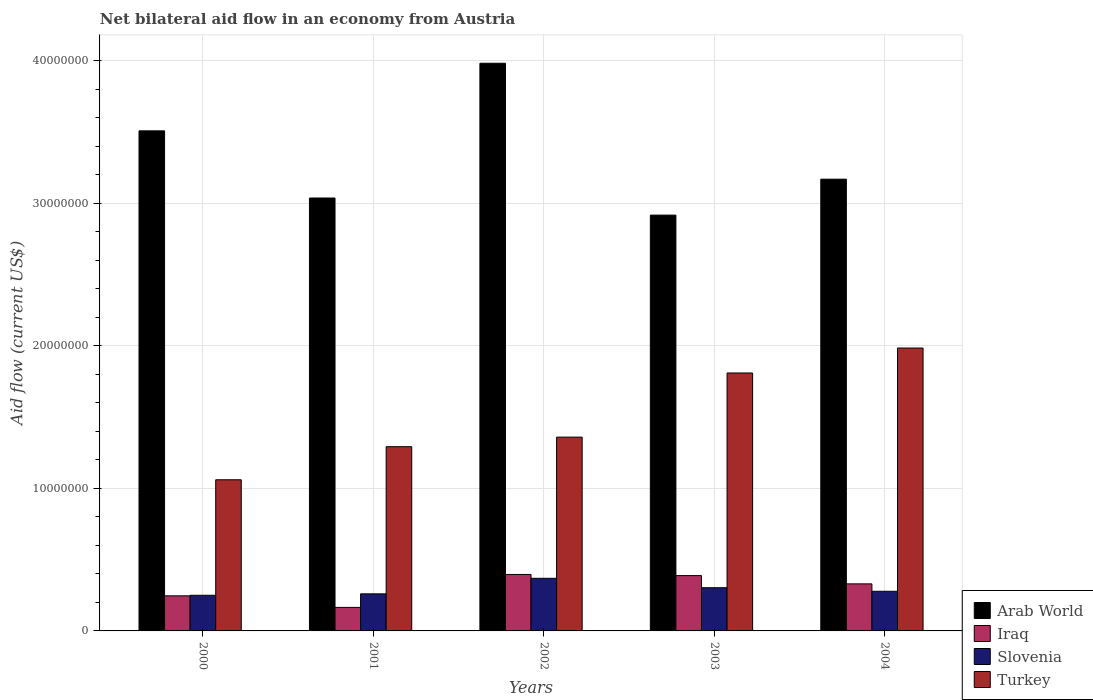Are the number of bars on each tick of the X-axis equal?
Provide a succinct answer. Yes. How many bars are there on the 4th tick from the left?
Offer a terse response. 4. What is the net bilateral aid flow in Iraq in 2002?
Ensure brevity in your answer.  3.96e+06. Across all years, what is the maximum net bilateral aid flow in Arab World?
Give a very brief answer. 3.98e+07. Across all years, what is the minimum net bilateral aid flow in Iraq?
Keep it short and to the point. 1.65e+06. In which year was the net bilateral aid flow in Iraq maximum?
Offer a terse response. 2002. What is the total net bilateral aid flow in Slovenia in the graph?
Offer a terse response. 1.46e+07. What is the difference between the net bilateral aid flow in Slovenia in 2001 and the net bilateral aid flow in Iraq in 2002?
Provide a succinct answer. -1.36e+06. What is the average net bilateral aid flow in Turkey per year?
Provide a short and direct response. 1.50e+07. In the year 2004, what is the difference between the net bilateral aid flow in Iraq and net bilateral aid flow in Turkey?
Ensure brevity in your answer.  -1.65e+07. What is the ratio of the net bilateral aid flow in Arab World in 2000 to that in 2003?
Provide a succinct answer. 1.2. What is the difference between the highest and the lowest net bilateral aid flow in Arab World?
Offer a very short reply. 1.06e+07. Is the sum of the net bilateral aid flow in Iraq in 2001 and 2004 greater than the maximum net bilateral aid flow in Slovenia across all years?
Provide a short and direct response. Yes. Is it the case that in every year, the sum of the net bilateral aid flow in Slovenia and net bilateral aid flow in Turkey is greater than the sum of net bilateral aid flow in Iraq and net bilateral aid flow in Arab World?
Provide a short and direct response. No. What does the 2nd bar from the left in 2003 represents?
Offer a very short reply. Iraq. How many years are there in the graph?
Make the answer very short. 5. What is the difference between two consecutive major ticks on the Y-axis?
Make the answer very short. 1.00e+07. Does the graph contain any zero values?
Offer a terse response. No. Where does the legend appear in the graph?
Provide a succinct answer. Bottom right. What is the title of the graph?
Your response must be concise. Net bilateral aid flow in an economy from Austria. What is the label or title of the X-axis?
Offer a very short reply. Years. What is the label or title of the Y-axis?
Provide a short and direct response. Aid flow (current US$). What is the Aid flow (current US$) in Arab World in 2000?
Your answer should be compact. 3.51e+07. What is the Aid flow (current US$) in Iraq in 2000?
Make the answer very short. 2.46e+06. What is the Aid flow (current US$) of Slovenia in 2000?
Give a very brief answer. 2.50e+06. What is the Aid flow (current US$) in Turkey in 2000?
Offer a terse response. 1.06e+07. What is the Aid flow (current US$) in Arab World in 2001?
Provide a succinct answer. 3.04e+07. What is the Aid flow (current US$) in Iraq in 2001?
Offer a terse response. 1.65e+06. What is the Aid flow (current US$) of Slovenia in 2001?
Your answer should be compact. 2.60e+06. What is the Aid flow (current US$) of Turkey in 2001?
Provide a succinct answer. 1.29e+07. What is the Aid flow (current US$) of Arab World in 2002?
Give a very brief answer. 3.98e+07. What is the Aid flow (current US$) in Iraq in 2002?
Give a very brief answer. 3.96e+06. What is the Aid flow (current US$) in Slovenia in 2002?
Your answer should be compact. 3.69e+06. What is the Aid flow (current US$) in Turkey in 2002?
Provide a succinct answer. 1.36e+07. What is the Aid flow (current US$) of Arab World in 2003?
Your answer should be very brief. 2.92e+07. What is the Aid flow (current US$) in Iraq in 2003?
Your response must be concise. 3.88e+06. What is the Aid flow (current US$) in Slovenia in 2003?
Give a very brief answer. 3.03e+06. What is the Aid flow (current US$) in Turkey in 2003?
Offer a terse response. 1.81e+07. What is the Aid flow (current US$) of Arab World in 2004?
Your response must be concise. 3.17e+07. What is the Aid flow (current US$) of Iraq in 2004?
Make the answer very short. 3.30e+06. What is the Aid flow (current US$) in Slovenia in 2004?
Your answer should be very brief. 2.78e+06. What is the Aid flow (current US$) in Turkey in 2004?
Give a very brief answer. 1.98e+07. Across all years, what is the maximum Aid flow (current US$) in Arab World?
Provide a succinct answer. 3.98e+07. Across all years, what is the maximum Aid flow (current US$) in Iraq?
Make the answer very short. 3.96e+06. Across all years, what is the maximum Aid flow (current US$) of Slovenia?
Your answer should be very brief. 3.69e+06. Across all years, what is the maximum Aid flow (current US$) of Turkey?
Keep it short and to the point. 1.98e+07. Across all years, what is the minimum Aid flow (current US$) in Arab World?
Your answer should be very brief. 2.92e+07. Across all years, what is the minimum Aid flow (current US$) in Iraq?
Keep it short and to the point. 1.65e+06. Across all years, what is the minimum Aid flow (current US$) of Slovenia?
Give a very brief answer. 2.50e+06. Across all years, what is the minimum Aid flow (current US$) of Turkey?
Make the answer very short. 1.06e+07. What is the total Aid flow (current US$) of Arab World in the graph?
Your response must be concise. 1.66e+08. What is the total Aid flow (current US$) in Iraq in the graph?
Ensure brevity in your answer.  1.52e+07. What is the total Aid flow (current US$) in Slovenia in the graph?
Provide a short and direct response. 1.46e+07. What is the total Aid flow (current US$) of Turkey in the graph?
Make the answer very short. 7.50e+07. What is the difference between the Aid flow (current US$) of Arab World in 2000 and that in 2001?
Ensure brevity in your answer.  4.71e+06. What is the difference between the Aid flow (current US$) in Iraq in 2000 and that in 2001?
Your response must be concise. 8.10e+05. What is the difference between the Aid flow (current US$) in Turkey in 2000 and that in 2001?
Make the answer very short. -2.32e+06. What is the difference between the Aid flow (current US$) of Arab World in 2000 and that in 2002?
Give a very brief answer. -4.74e+06. What is the difference between the Aid flow (current US$) in Iraq in 2000 and that in 2002?
Offer a terse response. -1.50e+06. What is the difference between the Aid flow (current US$) in Slovenia in 2000 and that in 2002?
Provide a succinct answer. -1.19e+06. What is the difference between the Aid flow (current US$) of Turkey in 2000 and that in 2002?
Ensure brevity in your answer.  -2.99e+06. What is the difference between the Aid flow (current US$) of Arab World in 2000 and that in 2003?
Keep it short and to the point. 5.91e+06. What is the difference between the Aid flow (current US$) of Iraq in 2000 and that in 2003?
Offer a terse response. -1.42e+06. What is the difference between the Aid flow (current US$) in Slovenia in 2000 and that in 2003?
Your answer should be very brief. -5.30e+05. What is the difference between the Aid flow (current US$) in Turkey in 2000 and that in 2003?
Give a very brief answer. -7.49e+06. What is the difference between the Aid flow (current US$) of Arab World in 2000 and that in 2004?
Make the answer very short. 3.39e+06. What is the difference between the Aid flow (current US$) of Iraq in 2000 and that in 2004?
Offer a very short reply. -8.40e+05. What is the difference between the Aid flow (current US$) in Slovenia in 2000 and that in 2004?
Offer a terse response. -2.80e+05. What is the difference between the Aid flow (current US$) of Turkey in 2000 and that in 2004?
Offer a very short reply. -9.24e+06. What is the difference between the Aid flow (current US$) of Arab World in 2001 and that in 2002?
Your answer should be very brief. -9.45e+06. What is the difference between the Aid flow (current US$) of Iraq in 2001 and that in 2002?
Your answer should be compact. -2.31e+06. What is the difference between the Aid flow (current US$) of Slovenia in 2001 and that in 2002?
Give a very brief answer. -1.09e+06. What is the difference between the Aid flow (current US$) in Turkey in 2001 and that in 2002?
Your answer should be compact. -6.70e+05. What is the difference between the Aid flow (current US$) in Arab World in 2001 and that in 2003?
Your answer should be compact. 1.20e+06. What is the difference between the Aid flow (current US$) of Iraq in 2001 and that in 2003?
Ensure brevity in your answer.  -2.23e+06. What is the difference between the Aid flow (current US$) in Slovenia in 2001 and that in 2003?
Keep it short and to the point. -4.30e+05. What is the difference between the Aid flow (current US$) of Turkey in 2001 and that in 2003?
Your answer should be compact. -5.17e+06. What is the difference between the Aid flow (current US$) in Arab World in 2001 and that in 2004?
Your answer should be very brief. -1.32e+06. What is the difference between the Aid flow (current US$) of Iraq in 2001 and that in 2004?
Your response must be concise. -1.65e+06. What is the difference between the Aid flow (current US$) in Turkey in 2001 and that in 2004?
Provide a short and direct response. -6.92e+06. What is the difference between the Aid flow (current US$) in Arab World in 2002 and that in 2003?
Make the answer very short. 1.06e+07. What is the difference between the Aid flow (current US$) of Turkey in 2002 and that in 2003?
Provide a succinct answer. -4.50e+06. What is the difference between the Aid flow (current US$) of Arab World in 2002 and that in 2004?
Ensure brevity in your answer.  8.13e+06. What is the difference between the Aid flow (current US$) of Iraq in 2002 and that in 2004?
Provide a succinct answer. 6.60e+05. What is the difference between the Aid flow (current US$) in Slovenia in 2002 and that in 2004?
Keep it short and to the point. 9.10e+05. What is the difference between the Aid flow (current US$) of Turkey in 2002 and that in 2004?
Your answer should be compact. -6.25e+06. What is the difference between the Aid flow (current US$) of Arab World in 2003 and that in 2004?
Offer a terse response. -2.52e+06. What is the difference between the Aid flow (current US$) of Iraq in 2003 and that in 2004?
Your answer should be compact. 5.80e+05. What is the difference between the Aid flow (current US$) in Turkey in 2003 and that in 2004?
Provide a succinct answer. -1.75e+06. What is the difference between the Aid flow (current US$) of Arab World in 2000 and the Aid flow (current US$) of Iraq in 2001?
Provide a short and direct response. 3.34e+07. What is the difference between the Aid flow (current US$) in Arab World in 2000 and the Aid flow (current US$) in Slovenia in 2001?
Make the answer very short. 3.25e+07. What is the difference between the Aid flow (current US$) in Arab World in 2000 and the Aid flow (current US$) in Turkey in 2001?
Give a very brief answer. 2.22e+07. What is the difference between the Aid flow (current US$) of Iraq in 2000 and the Aid flow (current US$) of Turkey in 2001?
Your answer should be very brief. -1.05e+07. What is the difference between the Aid flow (current US$) in Slovenia in 2000 and the Aid flow (current US$) in Turkey in 2001?
Keep it short and to the point. -1.04e+07. What is the difference between the Aid flow (current US$) of Arab World in 2000 and the Aid flow (current US$) of Iraq in 2002?
Keep it short and to the point. 3.11e+07. What is the difference between the Aid flow (current US$) of Arab World in 2000 and the Aid flow (current US$) of Slovenia in 2002?
Give a very brief answer. 3.14e+07. What is the difference between the Aid flow (current US$) in Arab World in 2000 and the Aid flow (current US$) in Turkey in 2002?
Your response must be concise. 2.15e+07. What is the difference between the Aid flow (current US$) in Iraq in 2000 and the Aid flow (current US$) in Slovenia in 2002?
Your answer should be very brief. -1.23e+06. What is the difference between the Aid flow (current US$) of Iraq in 2000 and the Aid flow (current US$) of Turkey in 2002?
Provide a short and direct response. -1.11e+07. What is the difference between the Aid flow (current US$) of Slovenia in 2000 and the Aid flow (current US$) of Turkey in 2002?
Offer a terse response. -1.11e+07. What is the difference between the Aid flow (current US$) of Arab World in 2000 and the Aid flow (current US$) of Iraq in 2003?
Your answer should be compact. 3.12e+07. What is the difference between the Aid flow (current US$) of Arab World in 2000 and the Aid flow (current US$) of Slovenia in 2003?
Offer a terse response. 3.20e+07. What is the difference between the Aid flow (current US$) of Arab World in 2000 and the Aid flow (current US$) of Turkey in 2003?
Give a very brief answer. 1.70e+07. What is the difference between the Aid flow (current US$) of Iraq in 2000 and the Aid flow (current US$) of Slovenia in 2003?
Give a very brief answer. -5.70e+05. What is the difference between the Aid flow (current US$) of Iraq in 2000 and the Aid flow (current US$) of Turkey in 2003?
Your answer should be compact. -1.56e+07. What is the difference between the Aid flow (current US$) in Slovenia in 2000 and the Aid flow (current US$) in Turkey in 2003?
Your answer should be compact. -1.56e+07. What is the difference between the Aid flow (current US$) in Arab World in 2000 and the Aid flow (current US$) in Iraq in 2004?
Ensure brevity in your answer.  3.18e+07. What is the difference between the Aid flow (current US$) in Arab World in 2000 and the Aid flow (current US$) in Slovenia in 2004?
Your answer should be very brief. 3.23e+07. What is the difference between the Aid flow (current US$) in Arab World in 2000 and the Aid flow (current US$) in Turkey in 2004?
Give a very brief answer. 1.52e+07. What is the difference between the Aid flow (current US$) in Iraq in 2000 and the Aid flow (current US$) in Slovenia in 2004?
Offer a terse response. -3.20e+05. What is the difference between the Aid flow (current US$) in Iraq in 2000 and the Aid flow (current US$) in Turkey in 2004?
Ensure brevity in your answer.  -1.74e+07. What is the difference between the Aid flow (current US$) in Slovenia in 2000 and the Aid flow (current US$) in Turkey in 2004?
Provide a short and direct response. -1.73e+07. What is the difference between the Aid flow (current US$) in Arab World in 2001 and the Aid flow (current US$) in Iraq in 2002?
Your response must be concise. 2.64e+07. What is the difference between the Aid flow (current US$) of Arab World in 2001 and the Aid flow (current US$) of Slovenia in 2002?
Give a very brief answer. 2.67e+07. What is the difference between the Aid flow (current US$) in Arab World in 2001 and the Aid flow (current US$) in Turkey in 2002?
Offer a very short reply. 1.68e+07. What is the difference between the Aid flow (current US$) in Iraq in 2001 and the Aid flow (current US$) in Slovenia in 2002?
Keep it short and to the point. -2.04e+06. What is the difference between the Aid flow (current US$) of Iraq in 2001 and the Aid flow (current US$) of Turkey in 2002?
Provide a succinct answer. -1.19e+07. What is the difference between the Aid flow (current US$) in Slovenia in 2001 and the Aid flow (current US$) in Turkey in 2002?
Your response must be concise. -1.10e+07. What is the difference between the Aid flow (current US$) in Arab World in 2001 and the Aid flow (current US$) in Iraq in 2003?
Ensure brevity in your answer.  2.65e+07. What is the difference between the Aid flow (current US$) in Arab World in 2001 and the Aid flow (current US$) in Slovenia in 2003?
Offer a very short reply. 2.73e+07. What is the difference between the Aid flow (current US$) in Arab World in 2001 and the Aid flow (current US$) in Turkey in 2003?
Your response must be concise. 1.23e+07. What is the difference between the Aid flow (current US$) of Iraq in 2001 and the Aid flow (current US$) of Slovenia in 2003?
Make the answer very short. -1.38e+06. What is the difference between the Aid flow (current US$) in Iraq in 2001 and the Aid flow (current US$) in Turkey in 2003?
Provide a succinct answer. -1.64e+07. What is the difference between the Aid flow (current US$) of Slovenia in 2001 and the Aid flow (current US$) of Turkey in 2003?
Offer a terse response. -1.55e+07. What is the difference between the Aid flow (current US$) of Arab World in 2001 and the Aid flow (current US$) of Iraq in 2004?
Provide a succinct answer. 2.71e+07. What is the difference between the Aid flow (current US$) of Arab World in 2001 and the Aid flow (current US$) of Slovenia in 2004?
Provide a succinct answer. 2.76e+07. What is the difference between the Aid flow (current US$) of Arab World in 2001 and the Aid flow (current US$) of Turkey in 2004?
Give a very brief answer. 1.05e+07. What is the difference between the Aid flow (current US$) of Iraq in 2001 and the Aid flow (current US$) of Slovenia in 2004?
Make the answer very short. -1.13e+06. What is the difference between the Aid flow (current US$) in Iraq in 2001 and the Aid flow (current US$) in Turkey in 2004?
Ensure brevity in your answer.  -1.82e+07. What is the difference between the Aid flow (current US$) in Slovenia in 2001 and the Aid flow (current US$) in Turkey in 2004?
Your answer should be compact. -1.72e+07. What is the difference between the Aid flow (current US$) of Arab World in 2002 and the Aid flow (current US$) of Iraq in 2003?
Your response must be concise. 3.59e+07. What is the difference between the Aid flow (current US$) of Arab World in 2002 and the Aid flow (current US$) of Slovenia in 2003?
Your answer should be compact. 3.68e+07. What is the difference between the Aid flow (current US$) of Arab World in 2002 and the Aid flow (current US$) of Turkey in 2003?
Your answer should be compact. 2.17e+07. What is the difference between the Aid flow (current US$) in Iraq in 2002 and the Aid flow (current US$) in Slovenia in 2003?
Your response must be concise. 9.30e+05. What is the difference between the Aid flow (current US$) in Iraq in 2002 and the Aid flow (current US$) in Turkey in 2003?
Your response must be concise. -1.41e+07. What is the difference between the Aid flow (current US$) of Slovenia in 2002 and the Aid flow (current US$) of Turkey in 2003?
Provide a short and direct response. -1.44e+07. What is the difference between the Aid flow (current US$) of Arab World in 2002 and the Aid flow (current US$) of Iraq in 2004?
Your answer should be compact. 3.65e+07. What is the difference between the Aid flow (current US$) in Arab World in 2002 and the Aid flow (current US$) in Slovenia in 2004?
Ensure brevity in your answer.  3.70e+07. What is the difference between the Aid flow (current US$) in Arab World in 2002 and the Aid flow (current US$) in Turkey in 2004?
Provide a short and direct response. 2.00e+07. What is the difference between the Aid flow (current US$) in Iraq in 2002 and the Aid flow (current US$) in Slovenia in 2004?
Your answer should be very brief. 1.18e+06. What is the difference between the Aid flow (current US$) in Iraq in 2002 and the Aid flow (current US$) in Turkey in 2004?
Keep it short and to the point. -1.59e+07. What is the difference between the Aid flow (current US$) of Slovenia in 2002 and the Aid flow (current US$) of Turkey in 2004?
Give a very brief answer. -1.62e+07. What is the difference between the Aid flow (current US$) in Arab World in 2003 and the Aid flow (current US$) in Iraq in 2004?
Your answer should be compact. 2.59e+07. What is the difference between the Aid flow (current US$) in Arab World in 2003 and the Aid flow (current US$) in Slovenia in 2004?
Provide a short and direct response. 2.64e+07. What is the difference between the Aid flow (current US$) in Arab World in 2003 and the Aid flow (current US$) in Turkey in 2004?
Provide a succinct answer. 9.32e+06. What is the difference between the Aid flow (current US$) of Iraq in 2003 and the Aid flow (current US$) of Slovenia in 2004?
Ensure brevity in your answer.  1.10e+06. What is the difference between the Aid flow (current US$) in Iraq in 2003 and the Aid flow (current US$) in Turkey in 2004?
Provide a succinct answer. -1.60e+07. What is the difference between the Aid flow (current US$) in Slovenia in 2003 and the Aid flow (current US$) in Turkey in 2004?
Provide a short and direct response. -1.68e+07. What is the average Aid flow (current US$) of Arab World per year?
Offer a terse response. 3.32e+07. What is the average Aid flow (current US$) of Iraq per year?
Your answer should be very brief. 3.05e+06. What is the average Aid flow (current US$) in Slovenia per year?
Provide a short and direct response. 2.92e+06. What is the average Aid flow (current US$) in Turkey per year?
Give a very brief answer. 1.50e+07. In the year 2000, what is the difference between the Aid flow (current US$) in Arab World and Aid flow (current US$) in Iraq?
Give a very brief answer. 3.26e+07. In the year 2000, what is the difference between the Aid flow (current US$) in Arab World and Aid flow (current US$) in Slovenia?
Make the answer very short. 3.26e+07. In the year 2000, what is the difference between the Aid flow (current US$) in Arab World and Aid flow (current US$) in Turkey?
Provide a short and direct response. 2.45e+07. In the year 2000, what is the difference between the Aid flow (current US$) in Iraq and Aid flow (current US$) in Turkey?
Offer a terse response. -8.14e+06. In the year 2000, what is the difference between the Aid flow (current US$) in Slovenia and Aid flow (current US$) in Turkey?
Your answer should be very brief. -8.10e+06. In the year 2001, what is the difference between the Aid flow (current US$) of Arab World and Aid flow (current US$) of Iraq?
Ensure brevity in your answer.  2.87e+07. In the year 2001, what is the difference between the Aid flow (current US$) of Arab World and Aid flow (current US$) of Slovenia?
Provide a succinct answer. 2.78e+07. In the year 2001, what is the difference between the Aid flow (current US$) in Arab World and Aid flow (current US$) in Turkey?
Keep it short and to the point. 1.74e+07. In the year 2001, what is the difference between the Aid flow (current US$) in Iraq and Aid flow (current US$) in Slovenia?
Your answer should be compact. -9.50e+05. In the year 2001, what is the difference between the Aid flow (current US$) in Iraq and Aid flow (current US$) in Turkey?
Provide a succinct answer. -1.13e+07. In the year 2001, what is the difference between the Aid flow (current US$) in Slovenia and Aid flow (current US$) in Turkey?
Your response must be concise. -1.03e+07. In the year 2002, what is the difference between the Aid flow (current US$) in Arab World and Aid flow (current US$) in Iraq?
Your answer should be compact. 3.58e+07. In the year 2002, what is the difference between the Aid flow (current US$) of Arab World and Aid flow (current US$) of Slovenia?
Give a very brief answer. 3.61e+07. In the year 2002, what is the difference between the Aid flow (current US$) in Arab World and Aid flow (current US$) in Turkey?
Keep it short and to the point. 2.62e+07. In the year 2002, what is the difference between the Aid flow (current US$) in Iraq and Aid flow (current US$) in Turkey?
Provide a short and direct response. -9.63e+06. In the year 2002, what is the difference between the Aid flow (current US$) of Slovenia and Aid flow (current US$) of Turkey?
Keep it short and to the point. -9.90e+06. In the year 2003, what is the difference between the Aid flow (current US$) in Arab World and Aid flow (current US$) in Iraq?
Offer a terse response. 2.53e+07. In the year 2003, what is the difference between the Aid flow (current US$) in Arab World and Aid flow (current US$) in Slovenia?
Offer a very short reply. 2.61e+07. In the year 2003, what is the difference between the Aid flow (current US$) in Arab World and Aid flow (current US$) in Turkey?
Keep it short and to the point. 1.11e+07. In the year 2003, what is the difference between the Aid flow (current US$) of Iraq and Aid flow (current US$) of Slovenia?
Ensure brevity in your answer.  8.50e+05. In the year 2003, what is the difference between the Aid flow (current US$) of Iraq and Aid flow (current US$) of Turkey?
Your answer should be very brief. -1.42e+07. In the year 2003, what is the difference between the Aid flow (current US$) in Slovenia and Aid flow (current US$) in Turkey?
Give a very brief answer. -1.51e+07. In the year 2004, what is the difference between the Aid flow (current US$) of Arab World and Aid flow (current US$) of Iraq?
Give a very brief answer. 2.84e+07. In the year 2004, what is the difference between the Aid flow (current US$) in Arab World and Aid flow (current US$) in Slovenia?
Provide a succinct answer. 2.89e+07. In the year 2004, what is the difference between the Aid flow (current US$) of Arab World and Aid flow (current US$) of Turkey?
Ensure brevity in your answer.  1.18e+07. In the year 2004, what is the difference between the Aid flow (current US$) in Iraq and Aid flow (current US$) in Slovenia?
Provide a short and direct response. 5.20e+05. In the year 2004, what is the difference between the Aid flow (current US$) of Iraq and Aid flow (current US$) of Turkey?
Give a very brief answer. -1.65e+07. In the year 2004, what is the difference between the Aid flow (current US$) of Slovenia and Aid flow (current US$) of Turkey?
Keep it short and to the point. -1.71e+07. What is the ratio of the Aid flow (current US$) in Arab World in 2000 to that in 2001?
Your answer should be very brief. 1.16. What is the ratio of the Aid flow (current US$) in Iraq in 2000 to that in 2001?
Offer a very short reply. 1.49. What is the ratio of the Aid flow (current US$) in Slovenia in 2000 to that in 2001?
Your answer should be very brief. 0.96. What is the ratio of the Aid flow (current US$) of Turkey in 2000 to that in 2001?
Keep it short and to the point. 0.82. What is the ratio of the Aid flow (current US$) of Arab World in 2000 to that in 2002?
Offer a terse response. 0.88. What is the ratio of the Aid flow (current US$) in Iraq in 2000 to that in 2002?
Offer a very short reply. 0.62. What is the ratio of the Aid flow (current US$) in Slovenia in 2000 to that in 2002?
Your answer should be very brief. 0.68. What is the ratio of the Aid flow (current US$) in Turkey in 2000 to that in 2002?
Provide a short and direct response. 0.78. What is the ratio of the Aid flow (current US$) of Arab World in 2000 to that in 2003?
Make the answer very short. 1.2. What is the ratio of the Aid flow (current US$) of Iraq in 2000 to that in 2003?
Your answer should be very brief. 0.63. What is the ratio of the Aid flow (current US$) of Slovenia in 2000 to that in 2003?
Make the answer very short. 0.83. What is the ratio of the Aid flow (current US$) of Turkey in 2000 to that in 2003?
Your response must be concise. 0.59. What is the ratio of the Aid flow (current US$) of Arab World in 2000 to that in 2004?
Provide a short and direct response. 1.11. What is the ratio of the Aid flow (current US$) in Iraq in 2000 to that in 2004?
Give a very brief answer. 0.75. What is the ratio of the Aid flow (current US$) in Slovenia in 2000 to that in 2004?
Provide a succinct answer. 0.9. What is the ratio of the Aid flow (current US$) of Turkey in 2000 to that in 2004?
Ensure brevity in your answer.  0.53. What is the ratio of the Aid flow (current US$) of Arab World in 2001 to that in 2002?
Offer a terse response. 0.76. What is the ratio of the Aid flow (current US$) in Iraq in 2001 to that in 2002?
Your answer should be compact. 0.42. What is the ratio of the Aid flow (current US$) in Slovenia in 2001 to that in 2002?
Make the answer very short. 0.7. What is the ratio of the Aid flow (current US$) of Turkey in 2001 to that in 2002?
Your answer should be compact. 0.95. What is the ratio of the Aid flow (current US$) of Arab World in 2001 to that in 2003?
Offer a very short reply. 1.04. What is the ratio of the Aid flow (current US$) of Iraq in 2001 to that in 2003?
Keep it short and to the point. 0.43. What is the ratio of the Aid flow (current US$) in Slovenia in 2001 to that in 2003?
Make the answer very short. 0.86. What is the ratio of the Aid flow (current US$) in Turkey in 2001 to that in 2003?
Your response must be concise. 0.71. What is the ratio of the Aid flow (current US$) of Slovenia in 2001 to that in 2004?
Ensure brevity in your answer.  0.94. What is the ratio of the Aid flow (current US$) of Turkey in 2001 to that in 2004?
Offer a terse response. 0.65. What is the ratio of the Aid flow (current US$) in Arab World in 2002 to that in 2003?
Make the answer very short. 1.37. What is the ratio of the Aid flow (current US$) of Iraq in 2002 to that in 2003?
Provide a short and direct response. 1.02. What is the ratio of the Aid flow (current US$) in Slovenia in 2002 to that in 2003?
Provide a succinct answer. 1.22. What is the ratio of the Aid flow (current US$) in Turkey in 2002 to that in 2003?
Offer a very short reply. 0.75. What is the ratio of the Aid flow (current US$) of Arab World in 2002 to that in 2004?
Your response must be concise. 1.26. What is the ratio of the Aid flow (current US$) of Slovenia in 2002 to that in 2004?
Make the answer very short. 1.33. What is the ratio of the Aid flow (current US$) of Turkey in 2002 to that in 2004?
Your answer should be compact. 0.69. What is the ratio of the Aid flow (current US$) of Arab World in 2003 to that in 2004?
Keep it short and to the point. 0.92. What is the ratio of the Aid flow (current US$) of Iraq in 2003 to that in 2004?
Provide a succinct answer. 1.18. What is the ratio of the Aid flow (current US$) in Slovenia in 2003 to that in 2004?
Provide a short and direct response. 1.09. What is the ratio of the Aid flow (current US$) in Turkey in 2003 to that in 2004?
Provide a succinct answer. 0.91. What is the difference between the highest and the second highest Aid flow (current US$) of Arab World?
Your answer should be very brief. 4.74e+06. What is the difference between the highest and the second highest Aid flow (current US$) of Iraq?
Keep it short and to the point. 8.00e+04. What is the difference between the highest and the second highest Aid flow (current US$) of Slovenia?
Keep it short and to the point. 6.60e+05. What is the difference between the highest and the second highest Aid flow (current US$) in Turkey?
Offer a very short reply. 1.75e+06. What is the difference between the highest and the lowest Aid flow (current US$) of Arab World?
Ensure brevity in your answer.  1.06e+07. What is the difference between the highest and the lowest Aid flow (current US$) of Iraq?
Your response must be concise. 2.31e+06. What is the difference between the highest and the lowest Aid flow (current US$) in Slovenia?
Provide a short and direct response. 1.19e+06. What is the difference between the highest and the lowest Aid flow (current US$) in Turkey?
Make the answer very short. 9.24e+06. 